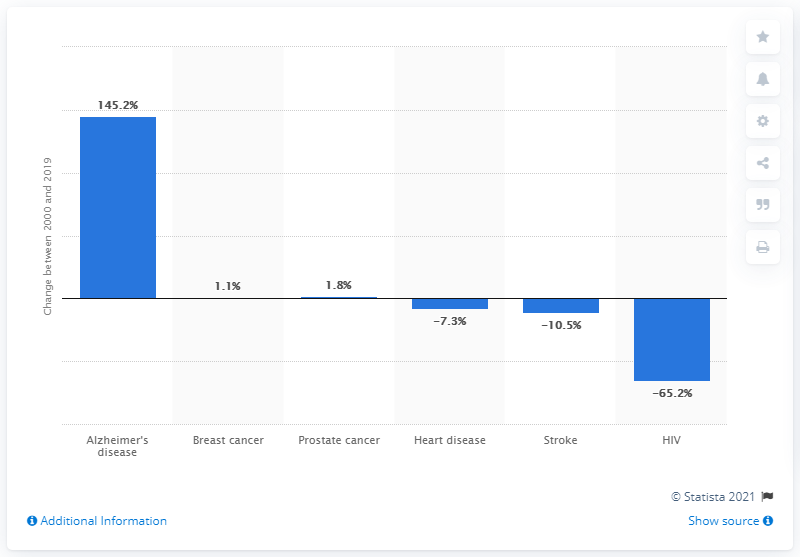Give some essential details in this illustration. The number of deaths caused by prostate cancer increased by 1.8% between 2000 and 2019. 